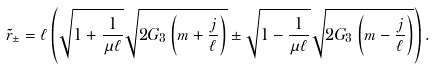<formula> <loc_0><loc_0><loc_500><loc_500>\tilde { r } _ { \pm } = \ell \left ( \sqrt { 1 + \frac { 1 } { \mu \ell } } \sqrt { 2 G _ { 3 } \left ( m + \frac { j } { \ell } \right ) } \pm \sqrt { 1 - \frac { 1 } { \mu \ell } } \sqrt { 2 G _ { 3 } \left ( m - \frac { j } { \ell } \right ) } \right ) .</formula> 